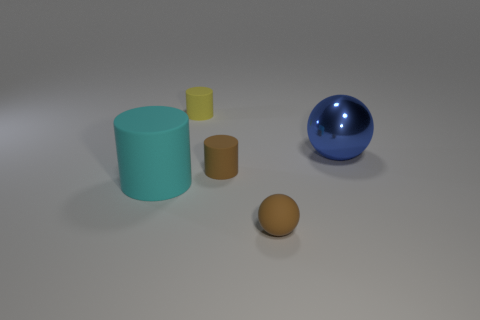Is there anything else that is made of the same material as the blue sphere?
Give a very brief answer. No. What is the size of the cyan thing that is the same shape as the yellow object?
Your answer should be very brief. Large. What number of small spheres have the same material as the small yellow object?
Your answer should be compact. 1. How many other small rubber balls are the same color as the tiny rubber sphere?
Offer a terse response. 0. What number of things are either brown spheres that are in front of the big cyan matte object or tiny matte cylinders that are in front of the tiny yellow rubber thing?
Ensure brevity in your answer.  2. Is the number of brown matte cylinders that are in front of the large matte cylinder less than the number of large cyan things?
Make the answer very short. Yes. Is there a blue metallic object that has the same size as the cyan object?
Offer a terse response. Yes. The big shiny object has what color?
Offer a terse response. Blue. Do the yellow rubber cylinder and the matte sphere have the same size?
Keep it short and to the point. Yes. What number of objects are tiny cyan metal cylinders or tiny brown rubber spheres?
Provide a succinct answer. 1. 